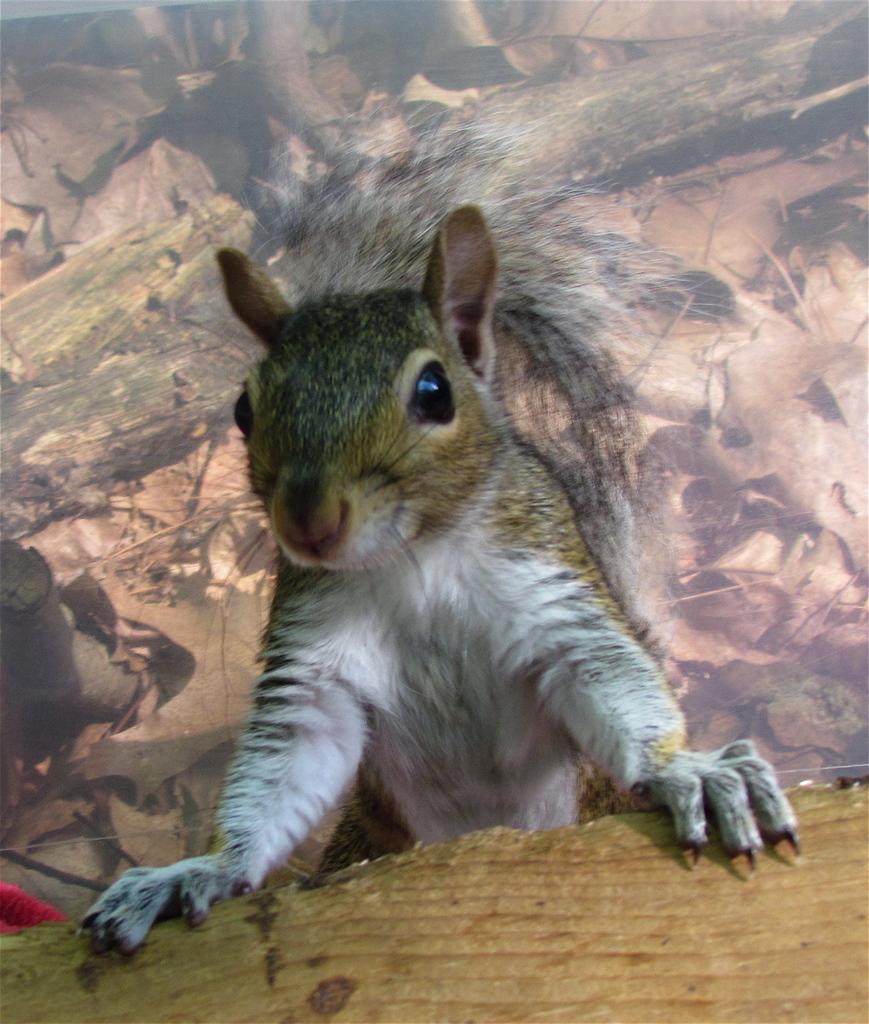Can you describe this image briefly? In this image in the center there is a squirrel. In the background there is painting on the wall. 